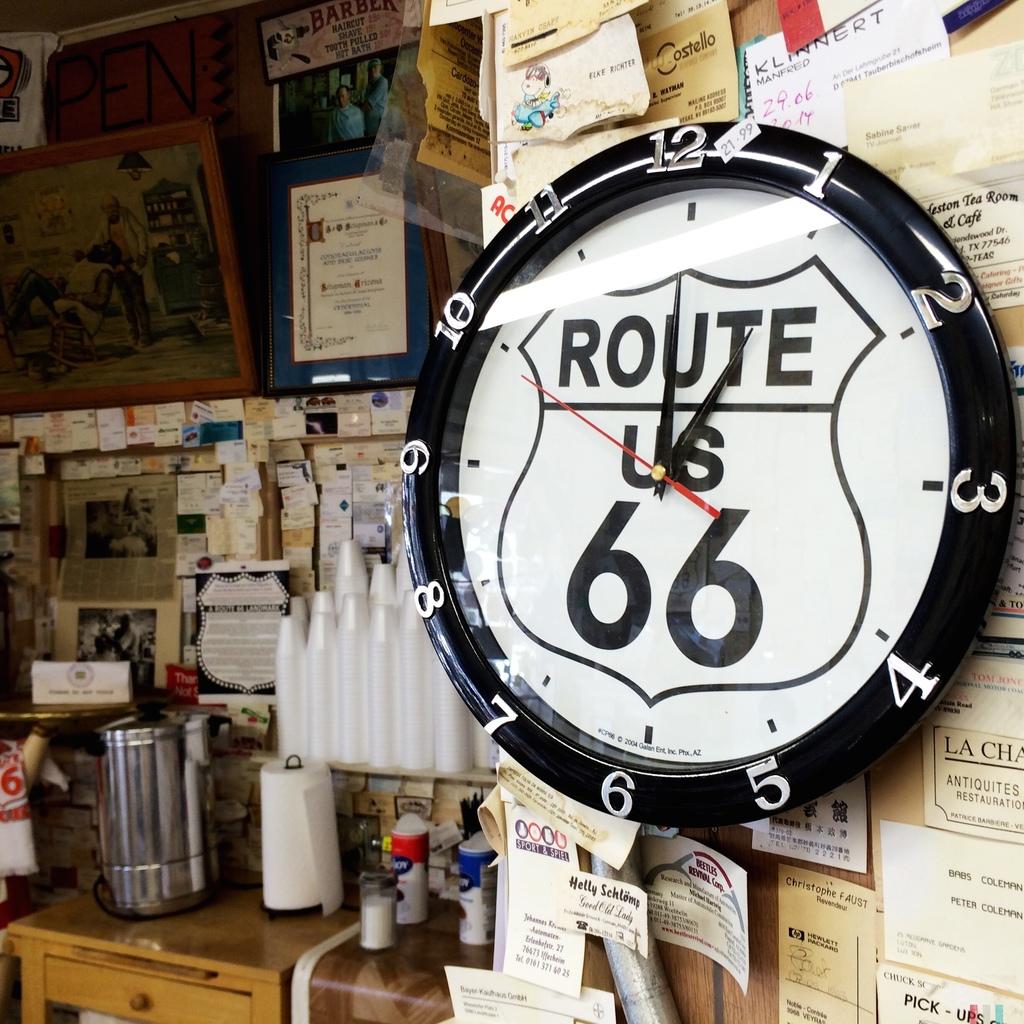What highway is on the clock?
Provide a short and direct response. Route 66. What is the number written on the clock?
Make the answer very short. 66. 